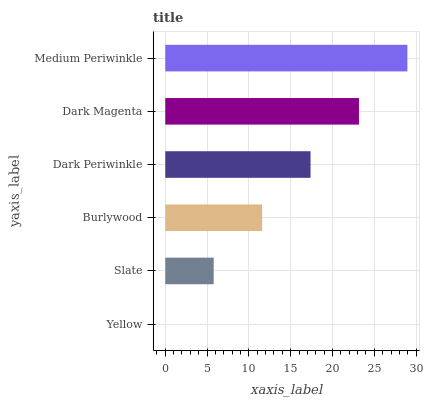Is Yellow the minimum?
Answer yes or no. Yes. Is Medium Periwinkle the maximum?
Answer yes or no. Yes. Is Slate the minimum?
Answer yes or no. No. Is Slate the maximum?
Answer yes or no. No. Is Slate greater than Yellow?
Answer yes or no. Yes. Is Yellow less than Slate?
Answer yes or no. Yes. Is Yellow greater than Slate?
Answer yes or no. No. Is Slate less than Yellow?
Answer yes or no. No. Is Dark Periwinkle the high median?
Answer yes or no. Yes. Is Burlywood the low median?
Answer yes or no. Yes. Is Burlywood the high median?
Answer yes or no. No. Is Dark Periwinkle the low median?
Answer yes or no. No. 